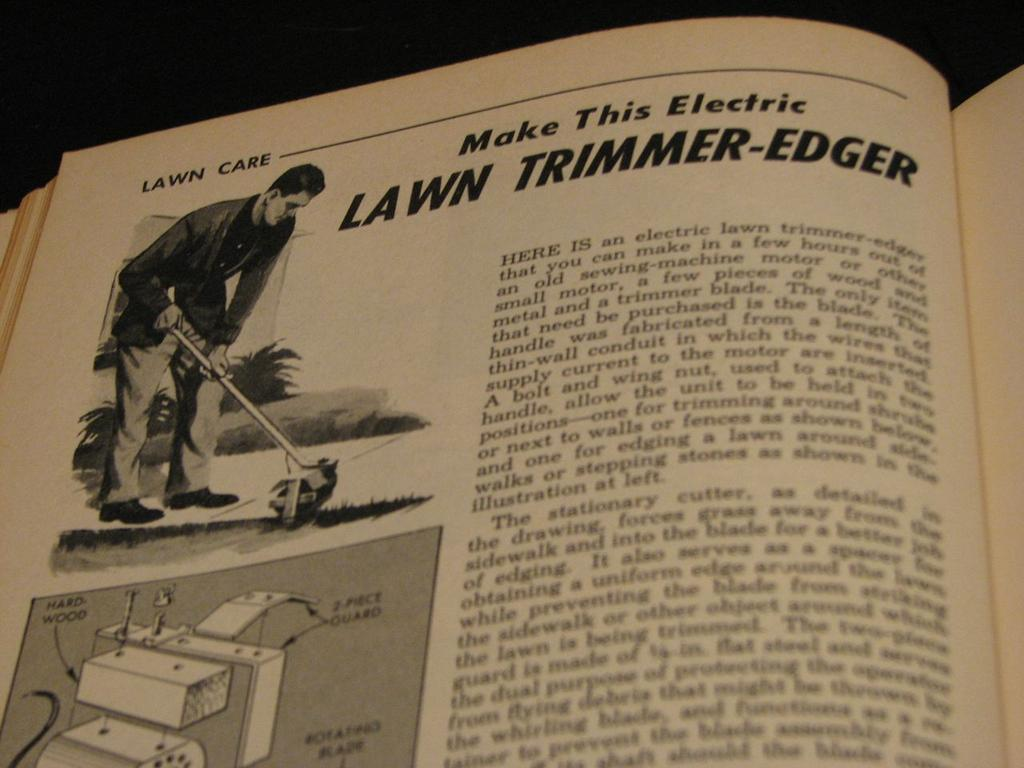<image>
Offer a succinct explanation of the picture presented. An article describing how to make a tool for trimming the edges of lawns. 